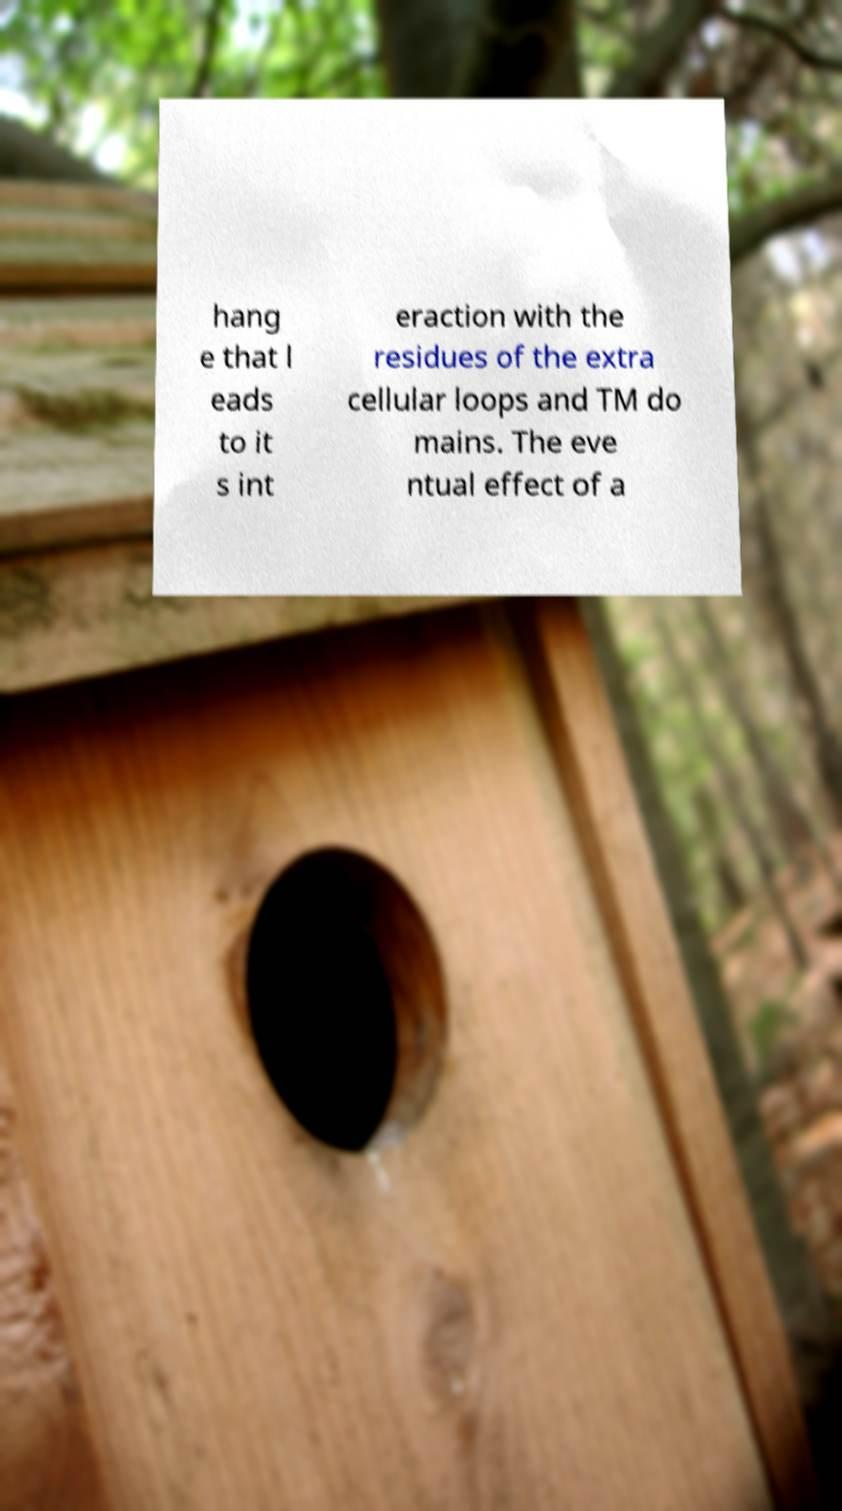Please read and relay the text visible in this image. What does it say? hang e that l eads to it s int eraction with the residues of the extra cellular loops and TM do mains. The eve ntual effect of a 